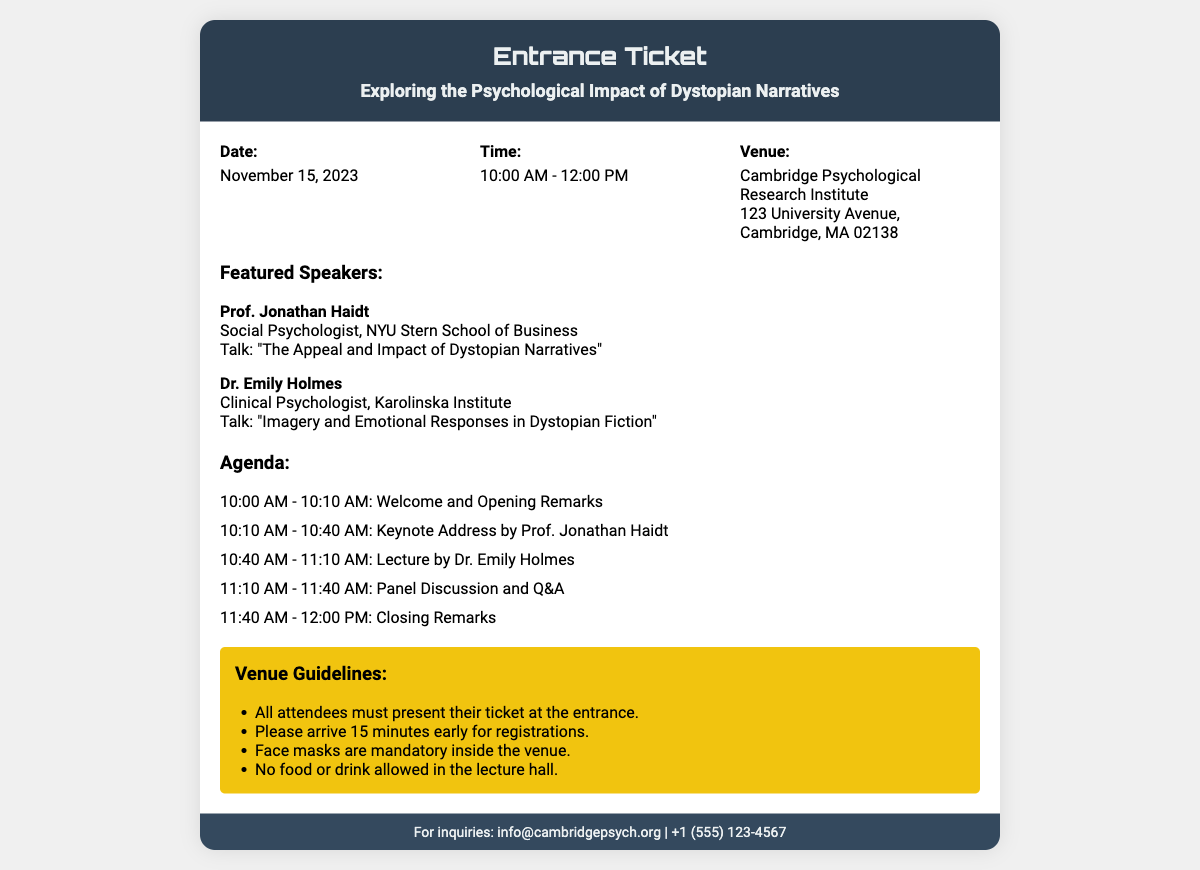What is the date of the lecture? The date of the lecture is specifically stated in the document, which is November 15, 2023.
Answer: November 15, 2023 Who is the first featured speaker? The document lists the speakers, the first being Prof. Jonathan Haidt, a social psychologist.
Answer: Prof. Jonathan Haidt What time does the lecture start? The starting time of the lecture is indicated and is 10:00 AM.
Answer: 10:00 AM What is the title of Dr. Emily Holmes' talk? The document specifies the talk title by Dr. Emily Holmes, which is "Imagery and Emotional Responses in Dystopian Fiction".
Answer: Imagery and Emotional Responses in Dystopian Fiction What is the venue for the lecture? The venue information is provided in the document, which states it is the Cambridge Psychological Research Institute.
Answer: Cambridge Psychological Research Institute How long is the keynote address? The agenda details the duration of the keynote address by Prof. Jonathan Haidt, which is 30 minutes.
Answer: 30 minutes What is required at the entrance of the venue? The venue guidelines mention that all attendees must present their ticket at the entrance.
Answer: Ticket What time should attendees arrive for registration? The guidelines state that attendees should arrive 15 minutes early for registrations.
Answer: 15 minutes early What will happen at 11:10 AM according to the agenda? The agenda outlines events, with the lecture by Dr. Emily Holmes scheduled for 11:10 AM.
Answer: Lecture by Dr. Emily Holmes 